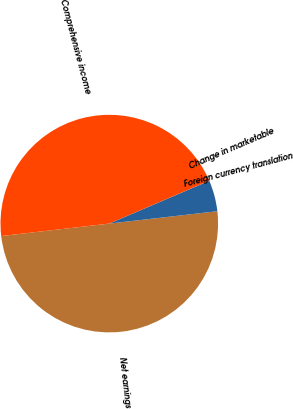Convert chart to OTSL. <chart><loc_0><loc_0><loc_500><loc_500><pie_chart><fcel>Net earnings<fcel>Foreign currency translation<fcel>Change in marketable<fcel>Comprehensive income<nl><fcel>49.99%<fcel>4.62%<fcel>0.01%<fcel>45.38%<nl></chart> 